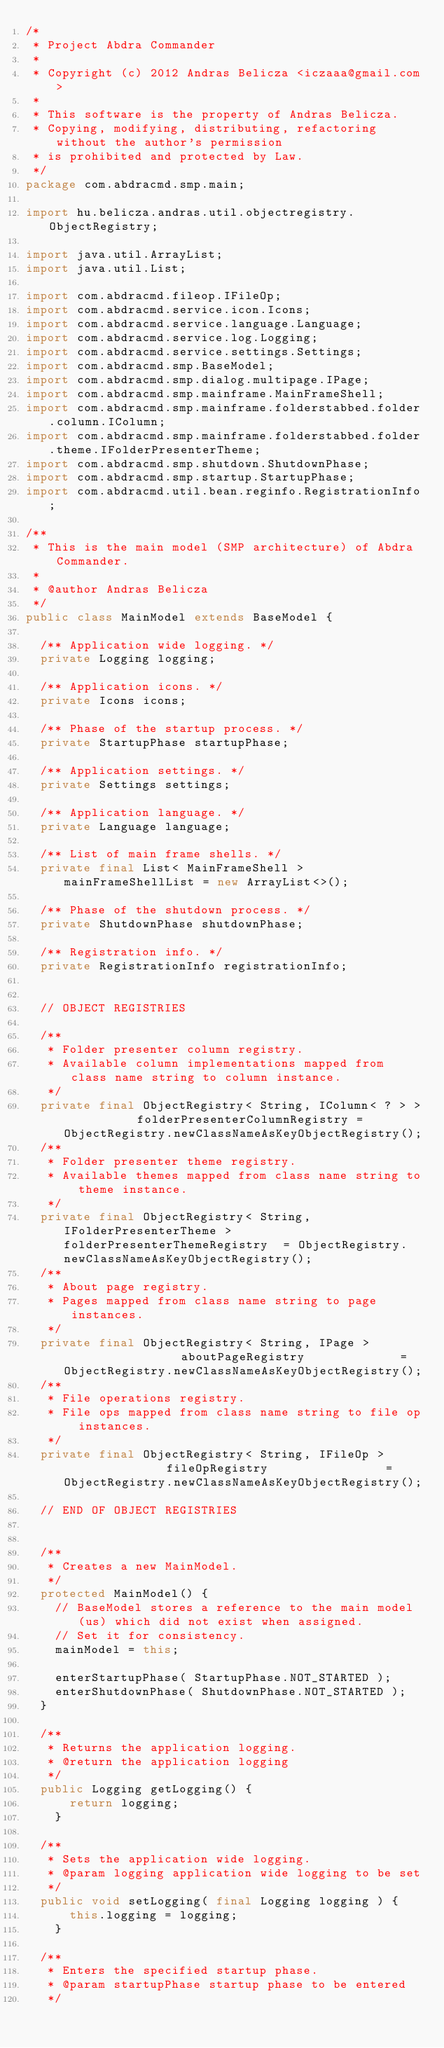Convert code to text. <code><loc_0><loc_0><loc_500><loc_500><_Java_>/*
 * Project Abdra Commander
 * 
 * Copyright (c) 2012 Andras Belicza <iczaaa@gmail.com>
 * 
 * This software is the property of Andras Belicza.
 * Copying, modifying, distributing, refactoring without the author's permission
 * is prohibited and protected by Law.
 */
package com.abdracmd.smp.main;

import hu.belicza.andras.util.objectregistry.ObjectRegistry;

import java.util.ArrayList;
import java.util.List;

import com.abdracmd.fileop.IFileOp;
import com.abdracmd.service.icon.Icons;
import com.abdracmd.service.language.Language;
import com.abdracmd.service.log.Logging;
import com.abdracmd.service.settings.Settings;
import com.abdracmd.smp.BaseModel;
import com.abdracmd.smp.dialog.multipage.IPage;
import com.abdracmd.smp.mainframe.MainFrameShell;
import com.abdracmd.smp.mainframe.folderstabbed.folder.column.IColumn;
import com.abdracmd.smp.mainframe.folderstabbed.folder.theme.IFolderPresenterTheme;
import com.abdracmd.smp.shutdown.ShutdownPhase;
import com.abdracmd.smp.startup.StartupPhase;
import com.abdracmd.util.bean.reginfo.RegistrationInfo;

/**
 * This is the main model (SMP architecture) of Abdra Commander.
 * 
 * @author Andras Belicza
 */
public class MainModel extends BaseModel {
	
	/** Application wide logging. */
	private Logging logging;
	
	/** Application icons. */
	private Icons icons;
	
	/** Phase of the startup process. */
	private StartupPhase startupPhase;
	
	/** Application settings. */
	private Settings settings;
	
	/** Application language. */
	private Language language;
	
	/** List of main frame shells. */
	private final List< MainFrameShell > mainFrameShellList = new ArrayList<>();
	
	/** Phase of the shutdown process. */
	private ShutdownPhase shutdownPhase;
	
	/** Registration info. */
	private RegistrationInfo registrationInfo;
	
	
	// OBJECT REGISTRIES
	
	/**
	 * Folder presenter column registry.
	 * Available column implementations mapped from class name string to column instance.
	 */
	private final ObjectRegistry< String, IColumn< ? > >          folderPresenterColumnRegistry = ObjectRegistry.newClassNameAsKeyObjectRegistry();
	/**
	 * Folder presenter theme registry.
	 * Available themes mapped from class name string to theme instance.
	 */
	private final ObjectRegistry< String, IFolderPresenterTheme > folderPresenterThemeRegistry  = ObjectRegistry.newClassNameAsKeyObjectRegistry();
	/**
	 * About page registry.
	 * Pages mapped from class name string to page instances.
	 */
	private final ObjectRegistry< String, IPage >                 aboutPageRegistry             = ObjectRegistry.newClassNameAsKeyObjectRegistry();
	/**
	 * File operations registry.
	 * File ops mapped from class name string to file op instances.
	 */
	private final ObjectRegistry< String, IFileOp >               fileOpRegistry                = ObjectRegistry.newClassNameAsKeyObjectRegistry();
	
	// END OF OBJECT REGISTRIES
	
	
	/**
	 * Creates a new MainModel.
	 */
	protected MainModel() {
		// BaseModel stores a reference to the main model (us) which did not exist when assigned.
		// Set it for consistency.
		mainModel = this;
		
		enterStartupPhase( StartupPhase.NOT_STARTED );
		enterShutdownPhase( ShutdownPhase.NOT_STARTED );
	}
	
	/**
	 * Returns the application logging.
	 * @return the application logging
	 */
	public Logging getLogging() {
	    return logging;
    }
	
	/**
	 * Sets the application wide logging.
	 * @param logging application wide logging to be set
	 */
	public void setLogging( final Logging logging ) {
	    this.logging = logging;
    }
	
	/**
	 * Enters the specified startup phase.
	 * @param startupPhase startup phase to be entered
	 */</code> 